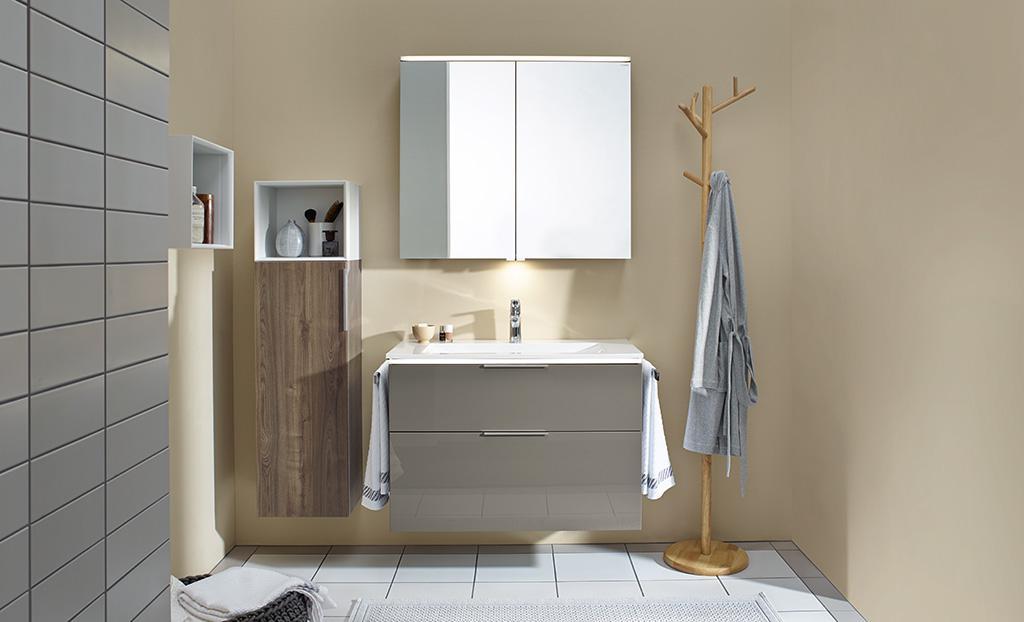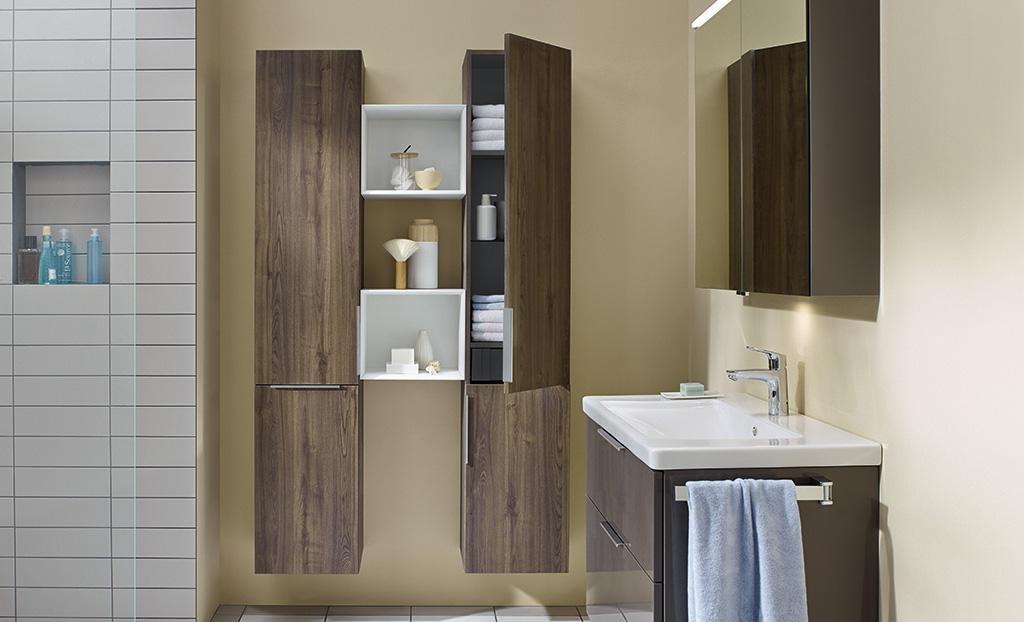The first image is the image on the left, the second image is the image on the right. For the images shown, is this caption "The right image shows a top-view of a rectangular single-basin sink with a wall-mounted vanity that has a chrome towel bar on the side." true? Answer yes or no. No. 